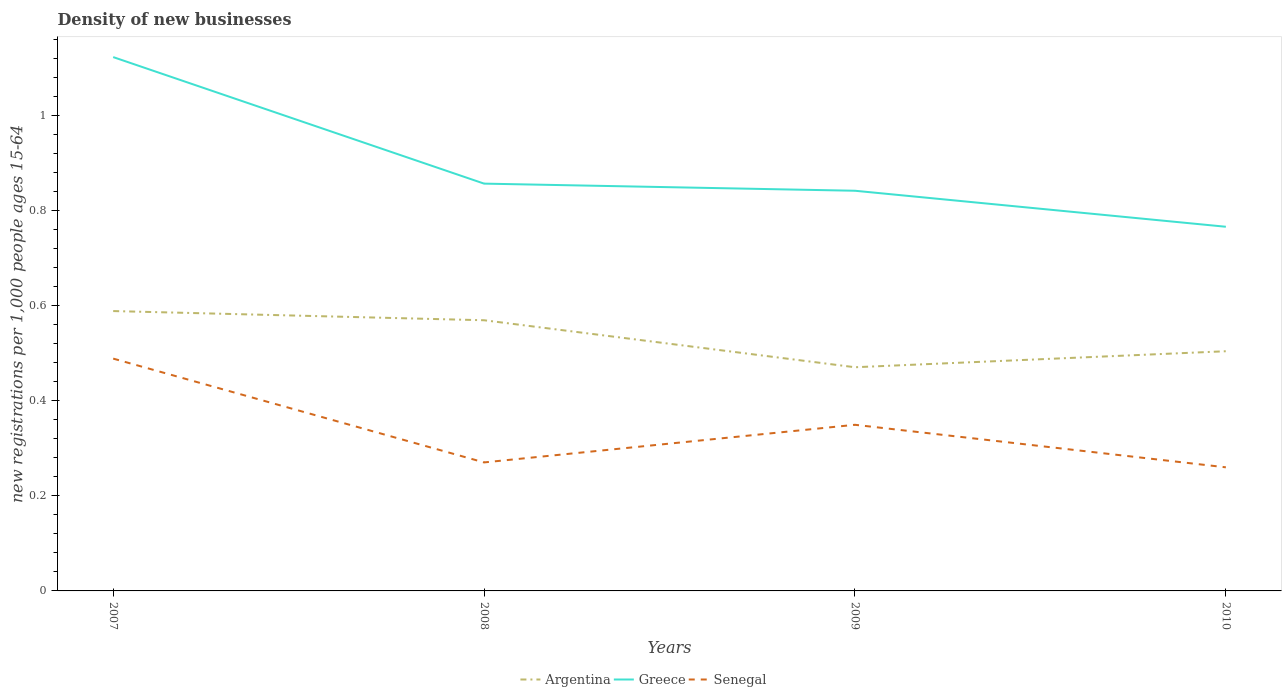Across all years, what is the maximum number of new registrations in Senegal?
Keep it short and to the point. 0.26. What is the total number of new registrations in Greece in the graph?
Offer a terse response. 0.36. What is the difference between the highest and the second highest number of new registrations in Argentina?
Provide a succinct answer. 0.12. What is the difference between the highest and the lowest number of new registrations in Senegal?
Make the answer very short. 2. Is the number of new registrations in Argentina strictly greater than the number of new registrations in Senegal over the years?
Give a very brief answer. No. How many lines are there?
Keep it short and to the point. 3. Does the graph contain any zero values?
Ensure brevity in your answer.  No. Does the graph contain grids?
Keep it short and to the point. No. What is the title of the graph?
Offer a terse response. Density of new businesses. Does "Afghanistan" appear as one of the legend labels in the graph?
Your answer should be very brief. No. What is the label or title of the X-axis?
Offer a very short reply. Years. What is the label or title of the Y-axis?
Provide a succinct answer. New registrations per 1,0 people ages 15-64. What is the new registrations per 1,000 people ages 15-64 in Argentina in 2007?
Ensure brevity in your answer.  0.59. What is the new registrations per 1,000 people ages 15-64 of Greece in 2007?
Make the answer very short. 1.12. What is the new registrations per 1,000 people ages 15-64 in Senegal in 2007?
Your response must be concise. 0.49. What is the new registrations per 1,000 people ages 15-64 in Argentina in 2008?
Your answer should be compact. 0.57. What is the new registrations per 1,000 people ages 15-64 in Greece in 2008?
Provide a succinct answer. 0.86. What is the new registrations per 1,000 people ages 15-64 in Senegal in 2008?
Make the answer very short. 0.27. What is the new registrations per 1,000 people ages 15-64 in Argentina in 2009?
Offer a terse response. 0.47. What is the new registrations per 1,000 people ages 15-64 of Greece in 2009?
Provide a succinct answer. 0.84. What is the new registrations per 1,000 people ages 15-64 in Senegal in 2009?
Your answer should be compact. 0.35. What is the new registrations per 1,000 people ages 15-64 of Argentina in 2010?
Your answer should be compact. 0.5. What is the new registrations per 1,000 people ages 15-64 of Greece in 2010?
Offer a terse response. 0.77. What is the new registrations per 1,000 people ages 15-64 in Senegal in 2010?
Give a very brief answer. 0.26. Across all years, what is the maximum new registrations per 1,000 people ages 15-64 of Argentina?
Ensure brevity in your answer.  0.59. Across all years, what is the maximum new registrations per 1,000 people ages 15-64 of Greece?
Your answer should be very brief. 1.12. Across all years, what is the maximum new registrations per 1,000 people ages 15-64 of Senegal?
Provide a short and direct response. 0.49. Across all years, what is the minimum new registrations per 1,000 people ages 15-64 in Argentina?
Your answer should be compact. 0.47. Across all years, what is the minimum new registrations per 1,000 people ages 15-64 in Greece?
Make the answer very short. 0.77. Across all years, what is the minimum new registrations per 1,000 people ages 15-64 of Senegal?
Your answer should be compact. 0.26. What is the total new registrations per 1,000 people ages 15-64 in Argentina in the graph?
Your answer should be very brief. 2.13. What is the total new registrations per 1,000 people ages 15-64 in Greece in the graph?
Provide a short and direct response. 3.59. What is the total new registrations per 1,000 people ages 15-64 in Senegal in the graph?
Your answer should be very brief. 1.37. What is the difference between the new registrations per 1,000 people ages 15-64 in Argentina in 2007 and that in 2008?
Provide a short and direct response. 0.02. What is the difference between the new registrations per 1,000 people ages 15-64 of Greece in 2007 and that in 2008?
Provide a short and direct response. 0.27. What is the difference between the new registrations per 1,000 people ages 15-64 in Senegal in 2007 and that in 2008?
Make the answer very short. 0.22. What is the difference between the new registrations per 1,000 people ages 15-64 of Argentina in 2007 and that in 2009?
Ensure brevity in your answer.  0.12. What is the difference between the new registrations per 1,000 people ages 15-64 in Greece in 2007 and that in 2009?
Give a very brief answer. 0.28. What is the difference between the new registrations per 1,000 people ages 15-64 of Senegal in 2007 and that in 2009?
Your answer should be very brief. 0.14. What is the difference between the new registrations per 1,000 people ages 15-64 of Argentina in 2007 and that in 2010?
Your answer should be compact. 0.08. What is the difference between the new registrations per 1,000 people ages 15-64 in Greece in 2007 and that in 2010?
Make the answer very short. 0.36. What is the difference between the new registrations per 1,000 people ages 15-64 in Senegal in 2007 and that in 2010?
Provide a succinct answer. 0.23. What is the difference between the new registrations per 1,000 people ages 15-64 in Argentina in 2008 and that in 2009?
Offer a terse response. 0.1. What is the difference between the new registrations per 1,000 people ages 15-64 of Greece in 2008 and that in 2009?
Offer a very short reply. 0.01. What is the difference between the new registrations per 1,000 people ages 15-64 in Senegal in 2008 and that in 2009?
Provide a short and direct response. -0.08. What is the difference between the new registrations per 1,000 people ages 15-64 in Argentina in 2008 and that in 2010?
Provide a succinct answer. 0.07. What is the difference between the new registrations per 1,000 people ages 15-64 in Greece in 2008 and that in 2010?
Provide a succinct answer. 0.09. What is the difference between the new registrations per 1,000 people ages 15-64 in Senegal in 2008 and that in 2010?
Your answer should be compact. 0.01. What is the difference between the new registrations per 1,000 people ages 15-64 of Argentina in 2009 and that in 2010?
Make the answer very short. -0.03. What is the difference between the new registrations per 1,000 people ages 15-64 in Greece in 2009 and that in 2010?
Give a very brief answer. 0.08. What is the difference between the new registrations per 1,000 people ages 15-64 in Senegal in 2009 and that in 2010?
Your answer should be very brief. 0.09. What is the difference between the new registrations per 1,000 people ages 15-64 in Argentina in 2007 and the new registrations per 1,000 people ages 15-64 in Greece in 2008?
Provide a succinct answer. -0.27. What is the difference between the new registrations per 1,000 people ages 15-64 in Argentina in 2007 and the new registrations per 1,000 people ages 15-64 in Senegal in 2008?
Make the answer very short. 0.32. What is the difference between the new registrations per 1,000 people ages 15-64 in Greece in 2007 and the new registrations per 1,000 people ages 15-64 in Senegal in 2008?
Give a very brief answer. 0.85. What is the difference between the new registrations per 1,000 people ages 15-64 of Argentina in 2007 and the new registrations per 1,000 people ages 15-64 of Greece in 2009?
Keep it short and to the point. -0.25. What is the difference between the new registrations per 1,000 people ages 15-64 of Argentina in 2007 and the new registrations per 1,000 people ages 15-64 of Senegal in 2009?
Provide a succinct answer. 0.24. What is the difference between the new registrations per 1,000 people ages 15-64 in Greece in 2007 and the new registrations per 1,000 people ages 15-64 in Senegal in 2009?
Keep it short and to the point. 0.77. What is the difference between the new registrations per 1,000 people ages 15-64 of Argentina in 2007 and the new registrations per 1,000 people ages 15-64 of Greece in 2010?
Your answer should be very brief. -0.18. What is the difference between the new registrations per 1,000 people ages 15-64 of Argentina in 2007 and the new registrations per 1,000 people ages 15-64 of Senegal in 2010?
Give a very brief answer. 0.33. What is the difference between the new registrations per 1,000 people ages 15-64 of Greece in 2007 and the new registrations per 1,000 people ages 15-64 of Senegal in 2010?
Give a very brief answer. 0.86. What is the difference between the new registrations per 1,000 people ages 15-64 of Argentina in 2008 and the new registrations per 1,000 people ages 15-64 of Greece in 2009?
Give a very brief answer. -0.27. What is the difference between the new registrations per 1,000 people ages 15-64 of Argentina in 2008 and the new registrations per 1,000 people ages 15-64 of Senegal in 2009?
Give a very brief answer. 0.22. What is the difference between the new registrations per 1,000 people ages 15-64 in Greece in 2008 and the new registrations per 1,000 people ages 15-64 in Senegal in 2009?
Keep it short and to the point. 0.51. What is the difference between the new registrations per 1,000 people ages 15-64 in Argentina in 2008 and the new registrations per 1,000 people ages 15-64 in Greece in 2010?
Offer a very short reply. -0.2. What is the difference between the new registrations per 1,000 people ages 15-64 in Argentina in 2008 and the new registrations per 1,000 people ages 15-64 in Senegal in 2010?
Your response must be concise. 0.31. What is the difference between the new registrations per 1,000 people ages 15-64 in Greece in 2008 and the new registrations per 1,000 people ages 15-64 in Senegal in 2010?
Offer a terse response. 0.6. What is the difference between the new registrations per 1,000 people ages 15-64 of Argentina in 2009 and the new registrations per 1,000 people ages 15-64 of Greece in 2010?
Ensure brevity in your answer.  -0.3. What is the difference between the new registrations per 1,000 people ages 15-64 in Argentina in 2009 and the new registrations per 1,000 people ages 15-64 in Senegal in 2010?
Make the answer very short. 0.21. What is the difference between the new registrations per 1,000 people ages 15-64 of Greece in 2009 and the new registrations per 1,000 people ages 15-64 of Senegal in 2010?
Provide a succinct answer. 0.58. What is the average new registrations per 1,000 people ages 15-64 of Argentina per year?
Your answer should be compact. 0.53. What is the average new registrations per 1,000 people ages 15-64 of Greece per year?
Your response must be concise. 0.9. What is the average new registrations per 1,000 people ages 15-64 of Senegal per year?
Give a very brief answer. 0.34. In the year 2007, what is the difference between the new registrations per 1,000 people ages 15-64 in Argentina and new registrations per 1,000 people ages 15-64 in Greece?
Keep it short and to the point. -0.53. In the year 2007, what is the difference between the new registrations per 1,000 people ages 15-64 of Argentina and new registrations per 1,000 people ages 15-64 of Senegal?
Make the answer very short. 0.1. In the year 2007, what is the difference between the new registrations per 1,000 people ages 15-64 of Greece and new registrations per 1,000 people ages 15-64 of Senegal?
Offer a very short reply. 0.63. In the year 2008, what is the difference between the new registrations per 1,000 people ages 15-64 in Argentina and new registrations per 1,000 people ages 15-64 in Greece?
Make the answer very short. -0.29. In the year 2008, what is the difference between the new registrations per 1,000 people ages 15-64 in Argentina and new registrations per 1,000 people ages 15-64 in Senegal?
Provide a short and direct response. 0.3. In the year 2008, what is the difference between the new registrations per 1,000 people ages 15-64 in Greece and new registrations per 1,000 people ages 15-64 in Senegal?
Your answer should be very brief. 0.59. In the year 2009, what is the difference between the new registrations per 1,000 people ages 15-64 in Argentina and new registrations per 1,000 people ages 15-64 in Greece?
Offer a terse response. -0.37. In the year 2009, what is the difference between the new registrations per 1,000 people ages 15-64 in Argentina and new registrations per 1,000 people ages 15-64 in Senegal?
Provide a short and direct response. 0.12. In the year 2009, what is the difference between the new registrations per 1,000 people ages 15-64 in Greece and new registrations per 1,000 people ages 15-64 in Senegal?
Provide a succinct answer. 0.49. In the year 2010, what is the difference between the new registrations per 1,000 people ages 15-64 of Argentina and new registrations per 1,000 people ages 15-64 of Greece?
Give a very brief answer. -0.26. In the year 2010, what is the difference between the new registrations per 1,000 people ages 15-64 in Argentina and new registrations per 1,000 people ages 15-64 in Senegal?
Provide a succinct answer. 0.24. In the year 2010, what is the difference between the new registrations per 1,000 people ages 15-64 in Greece and new registrations per 1,000 people ages 15-64 in Senegal?
Keep it short and to the point. 0.51. What is the ratio of the new registrations per 1,000 people ages 15-64 of Argentina in 2007 to that in 2008?
Make the answer very short. 1.03. What is the ratio of the new registrations per 1,000 people ages 15-64 of Greece in 2007 to that in 2008?
Ensure brevity in your answer.  1.31. What is the ratio of the new registrations per 1,000 people ages 15-64 in Senegal in 2007 to that in 2008?
Your answer should be compact. 1.81. What is the ratio of the new registrations per 1,000 people ages 15-64 of Argentina in 2007 to that in 2009?
Your answer should be very brief. 1.25. What is the ratio of the new registrations per 1,000 people ages 15-64 in Greece in 2007 to that in 2009?
Offer a terse response. 1.33. What is the ratio of the new registrations per 1,000 people ages 15-64 in Senegal in 2007 to that in 2009?
Your answer should be very brief. 1.4. What is the ratio of the new registrations per 1,000 people ages 15-64 in Argentina in 2007 to that in 2010?
Your response must be concise. 1.17. What is the ratio of the new registrations per 1,000 people ages 15-64 in Greece in 2007 to that in 2010?
Your response must be concise. 1.47. What is the ratio of the new registrations per 1,000 people ages 15-64 in Senegal in 2007 to that in 2010?
Give a very brief answer. 1.88. What is the ratio of the new registrations per 1,000 people ages 15-64 in Argentina in 2008 to that in 2009?
Provide a succinct answer. 1.21. What is the ratio of the new registrations per 1,000 people ages 15-64 in Greece in 2008 to that in 2009?
Provide a succinct answer. 1.02. What is the ratio of the new registrations per 1,000 people ages 15-64 of Senegal in 2008 to that in 2009?
Give a very brief answer. 0.77. What is the ratio of the new registrations per 1,000 people ages 15-64 in Argentina in 2008 to that in 2010?
Offer a terse response. 1.13. What is the ratio of the new registrations per 1,000 people ages 15-64 in Greece in 2008 to that in 2010?
Provide a succinct answer. 1.12. What is the ratio of the new registrations per 1,000 people ages 15-64 in Senegal in 2008 to that in 2010?
Your answer should be compact. 1.04. What is the ratio of the new registrations per 1,000 people ages 15-64 of Argentina in 2009 to that in 2010?
Give a very brief answer. 0.93. What is the ratio of the new registrations per 1,000 people ages 15-64 in Greece in 2009 to that in 2010?
Provide a succinct answer. 1.1. What is the ratio of the new registrations per 1,000 people ages 15-64 in Senegal in 2009 to that in 2010?
Your answer should be very brief. 1.34. What is the difference between the highest and the second highest new registrations per 1,000 people ages 15-64 of Argentina?
Make the answer very short. 0.02. What is the difference between the highest and the second highest new registrations per 1,000 people ages 15-64 of Greece?
Your answer should be very brief. 0.27. What is the difference between the highest and the second highest new registrations per 1,000 people ages 15-64 of Senegal?
Give a very brief answer. 0.14. What is the difference between the highest and the lowest new registrations per 1,000 people ages 15-64 in Argentina?
Provide a succinct answer. 0.12. What is the difference between the highest and the lowest new registrations per 1,000 people ages 15-64 of Greece?
Offer a very short reply. 0.36. What is the difference between the highest and the lowest new registrations per 1,000 people ages 15-64 in Senegal?
Your answer should be very brief. 0.23. 